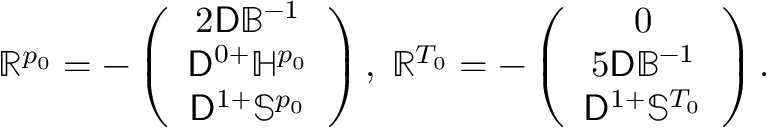<formula> <loc_0><loc_0><loc_500><loc_500>\mathbb { R } ^ { p _ { 0 } } = - \left ( \begin{array} { c } { 2 D \mathbb { B } ^ { - 1 } } \\ { D ^ { 0 + } \mathbb { H } ^ { p _ { 0 } } } \\ { D ^ { 1 + } \mathbb { S } ^ { p _ { 0 } } } \end{array} \right ) , \, \mathbb { R } ^ { T _ { 0 } } = - \left ( \begin{array} { c } { 0 } \\ { 5 D \mathbb { B } ^ { - 1 } } \\ { D ^ { 1 + } \mathbb { S } ^ { T _ { 0 } } } \end{array} \right ) .</formula> 